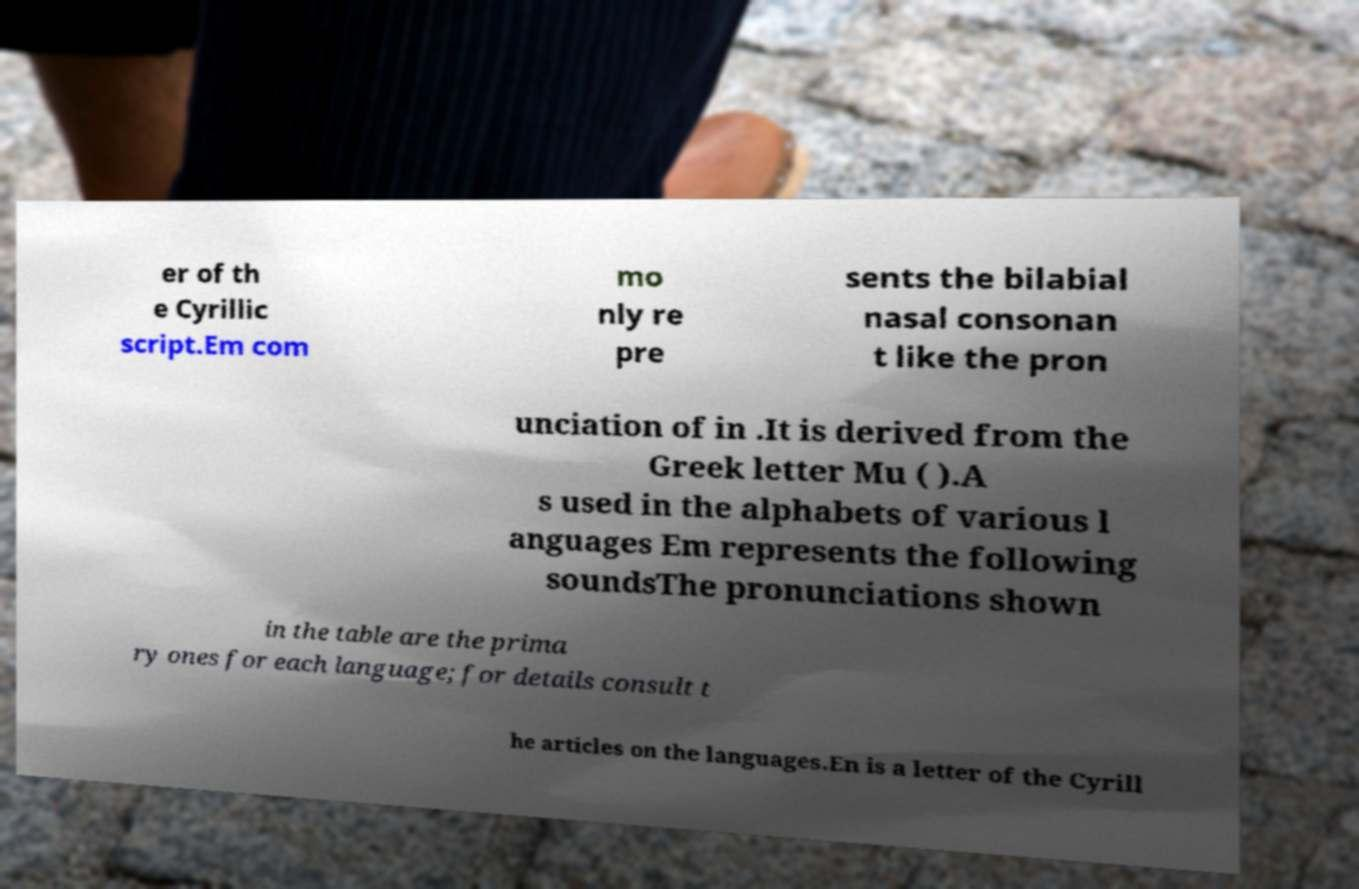There's text embedded in this image that I need extracted. Can you transcribe it verbatim? er of th e Cyrillic script.Em com mo nly re pre sents the bilabial nasal consonan t like the pron unciation of in .It is derived from the Greek letter Mu ( ).A s used in the alphabets of various l anguages Em represents the following soundsThe pronunciations shown in the table are the prima ry ones for each language; for details consult t he articles on the languages.En is a letter of the Cyrill 